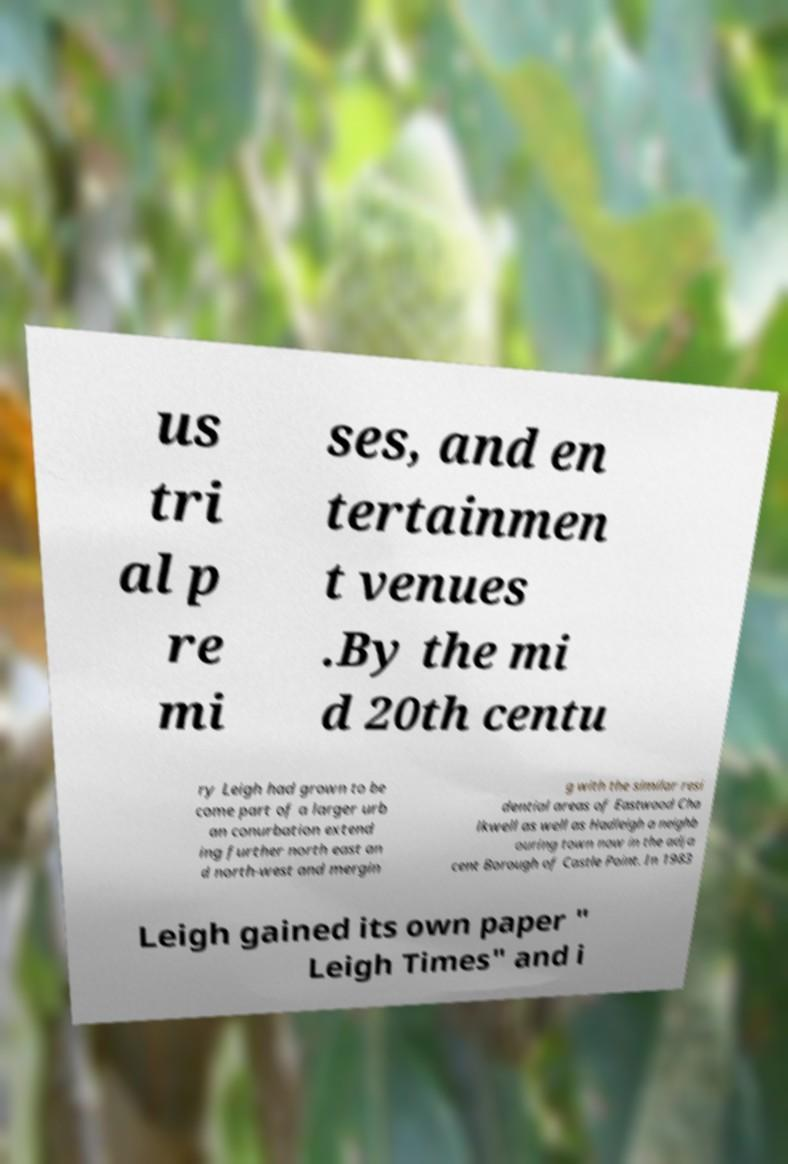What messages or text are displayed in this image? I need them in a readable, typed format. us tri al p re mi ses, and en tertainmen t venues .By the mi d 20th centu ry Leigh had grown to be come part of a larger urb an conurbation extend ing further north east an d north-west and mergin g with the similar resi dential areas of Eastwood Cha lkwell as well as Hadleigh a neighb ouring town now in the adja cent Borough of Castle Point. In 1983 Leigh gained its own paper " Leigh Times" and i 